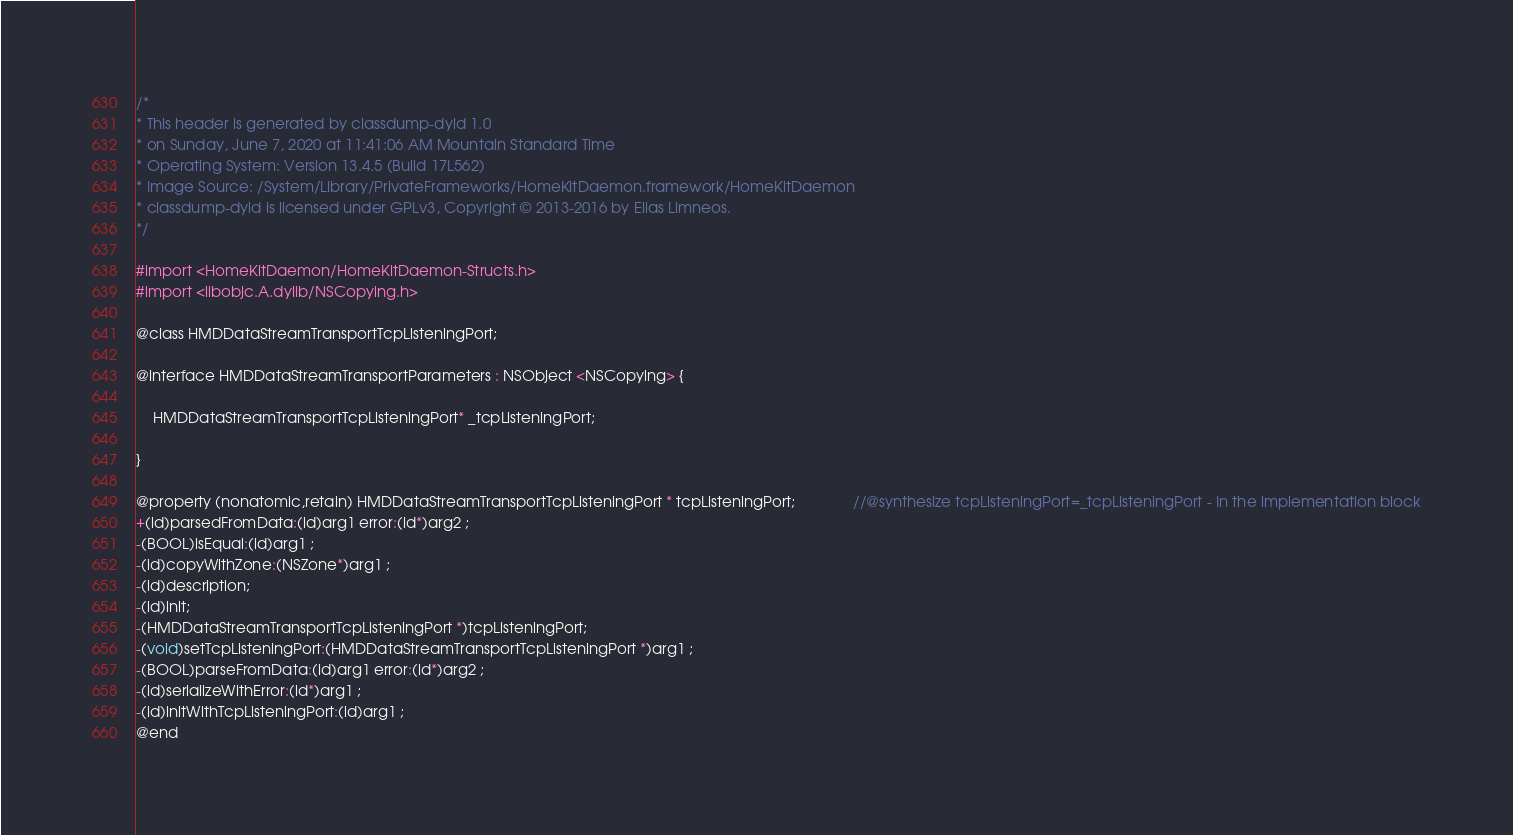<code> <loc_0><loc_0><loc_500><loc_500><_C_>/*
* This header is generated by classdump-dyld 1.0
* on Sunday, June 7, 2020 at 11:41:06 AM Mountain Standard Time
* Operating System: Version 13.4.5 (Build 17L562)
* Image Source: /System/Library/PrivateFrameworks/HomeKitDaemon.framework/HomeKitDaemon
* classdump-dyld is licensed under GPLv3, Copyright © 2013-2016 by Elias Limneos.
*/

#import <HomeKitDaemon/HomeKitDaemon-Structs.h>
#import <libobjc.A.dylib/NSCopying.h>

@class HMDDataStreamTransportTcpListeningPort;

@interface HMDDataStreamTransportParameters : NSObject <NSCopying> {

	HMDDataStreamTransportTcpListeningPort* _tcpListeningPort;

}

@property (nonatomic,retain) HMDDataStreamTransportTcpListeningPort * tcpListeningPort;              //@synthesize tcpListeningPort=_tcpListeningPort - In the implementation block
+(id)parsedFromData:(id)arg1 error:(id*)arg2 ;
-(BOOL)isEqual:(id)arg1 ;
-(id)copyWithZone:(NSZone*)arg1 ;
-(id)description;
-(id)init;
-(HMDDataStreamTransportTcpListeningPort *)tcpListeningPort;
-(void)setTcpListeningPort:(HMDDataStreamTransportTcpListeningPort *)arg1 ;
-(BOOL)parseFromData:(id)arg1 error:(id*)arg2 ;
-(id)serializeWithError:(id*)arg1 ;
-(id)initWithTcpListeningPort:(id)arg1 ;
@end

</code> 